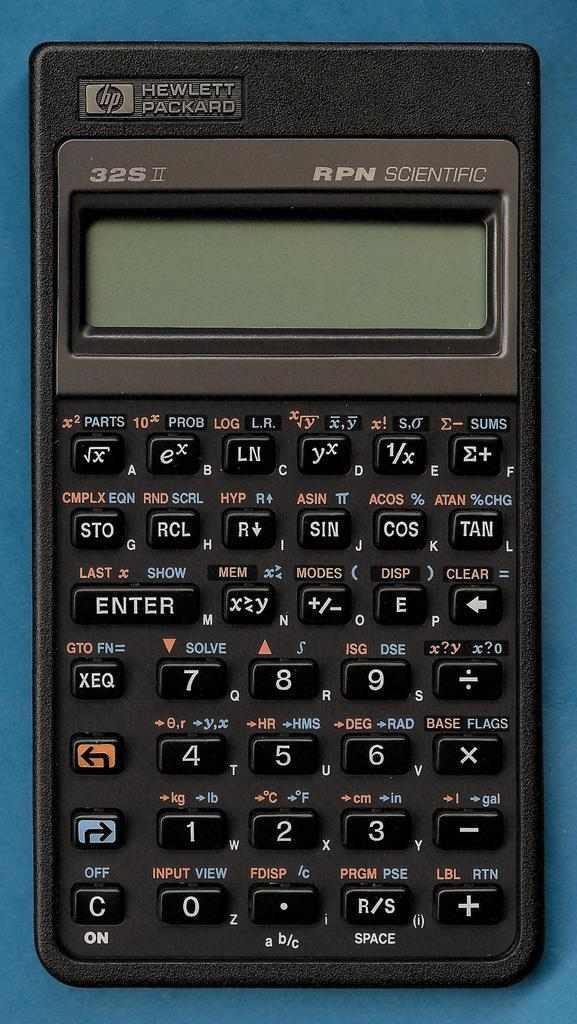What device is visible in the image? There is a calculator in the image. Where is the calculator located? The calculator is placed on a surface. What type of beetle can be seen crawling on the calculator in the image? There is no beetle present on the calculator in the image. 